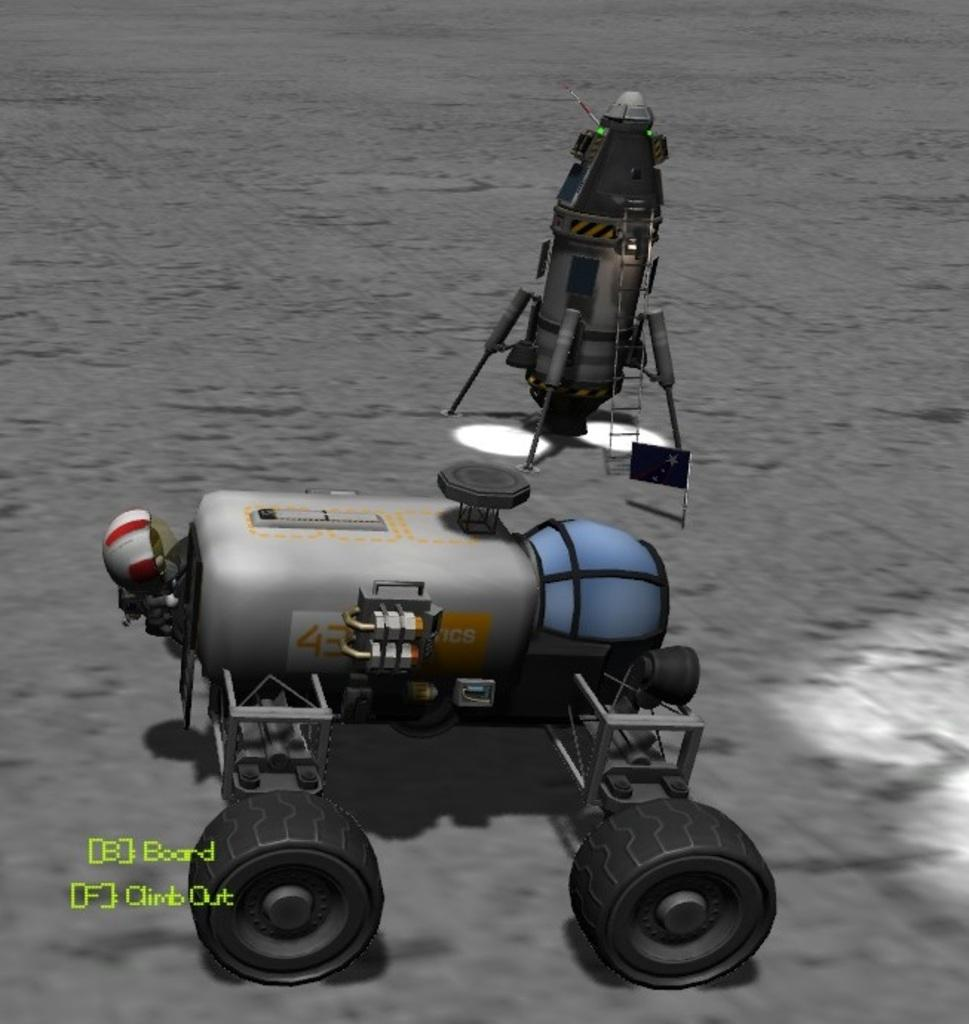<image>
Write a terse but informative summary of the picture. A graphic image of a robot with B for board and F to climb out. 